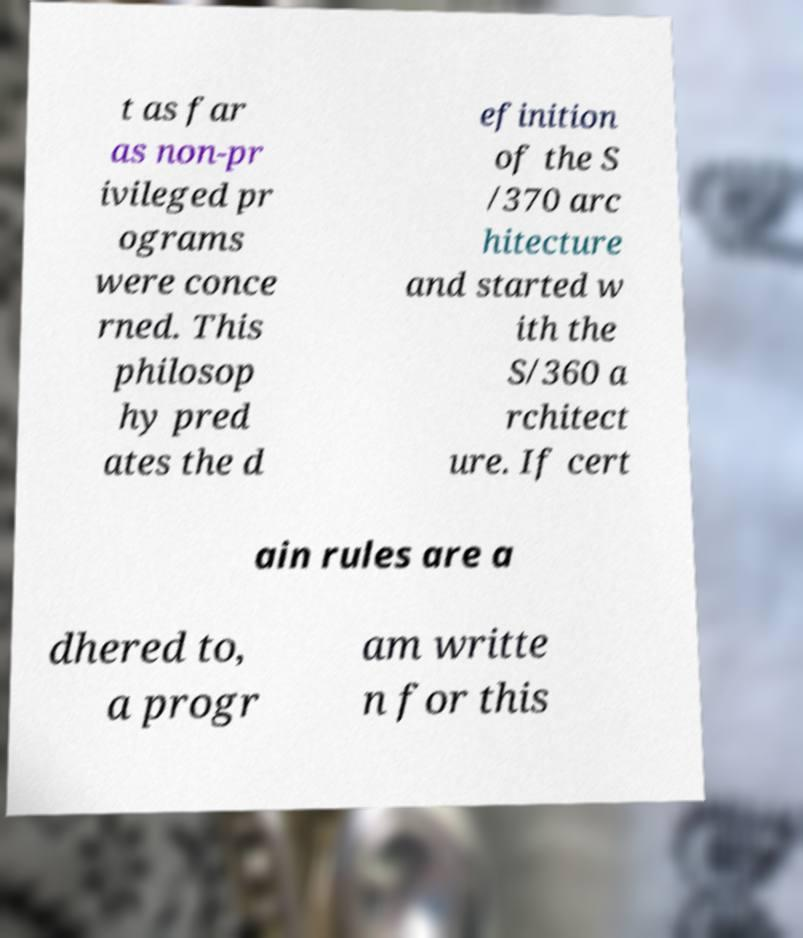Could you extract and type out the text from this image? t as far as non-pr ivileged pr ograms were conce rned. This philosop hy pred ates the d efinition of the S /370 arc hitecture and started w ith the S/360 a rchitect ure. If cert ain rules are a dhered to, a progr am writte n for this 